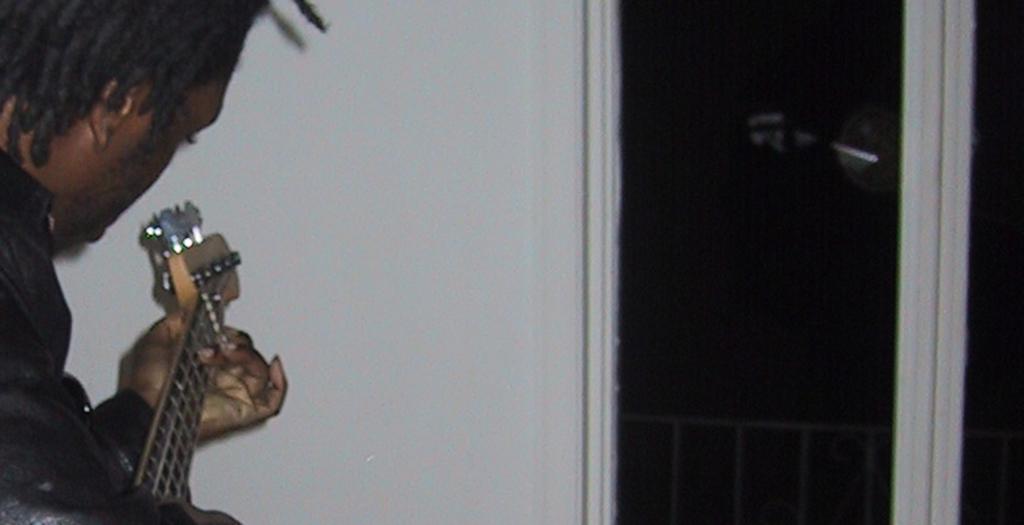Could you give a brief overview of what you see in this image? On the left side of the image we can see a man holding a guitar in his hands and playing it. 